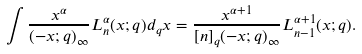Convert formula to latex. <formula><loc_0><loc_0><loc_500><loc_500>\int \frac { x ^ { \alpha } } { ( - x ; q ) _ { \infty } } L _ { n } ^ { \alpha } ( x ; q ) d _ { q } x = \frac { x ^ { \alpha + 1 } } { [ n ] _ { q } ( - x ; q ) _ { \infty } } L _ { n - 1 } ^ { \alpha + 1 } ( x ; q ) .</formula> 